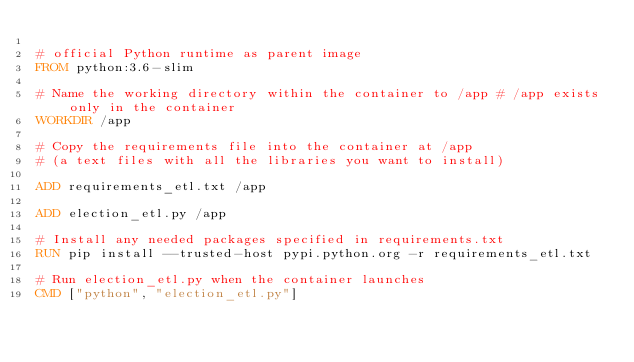Convert code to text. <code><loc_0><loc_0><loc_500><loc_500><_Dockerfile_>
# official Python runtime as parent image
FROM python:3.6-slim

# Name the working directory within the container to /app # /app exists only in the container
WORKDIR /app

# Copy the requirements file into the container at /app
# (a text files with all the libraries you want to install)

ADD requirements_etl.txt /app

ADD election_etl.py /app

# Install any needed packages specified in requirements.txt
RUN pip install --trusted-host pypi.python.org -r requirements_etl.txt

# Run election_etl.py when the container launches
CMD ["python", "election_etl.py"]
</code> 